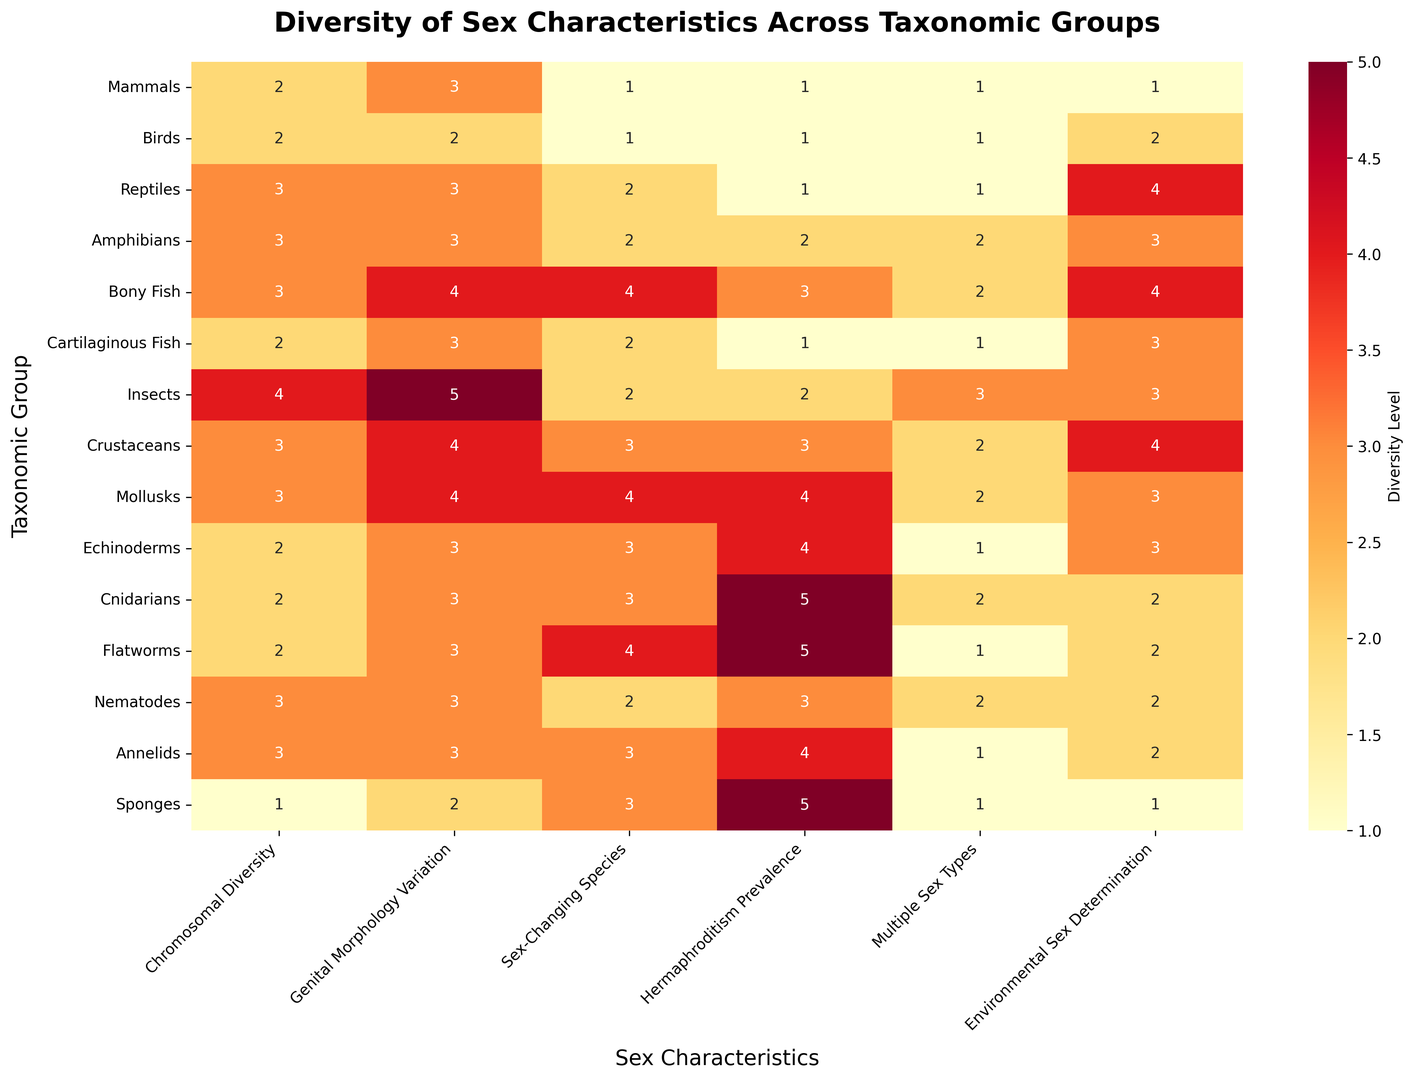Which taxonomic group has the highest level of hermaphroditism prevalence? Look for the cell with the highest value in the "Hermaphroditism Prevalence" column. Cnidarians and Flatworms both have the highest value of 5.
Answer: Cnidarians, Flatworms Which taxonomic group shows the most variation in genital morphology? Look for the highest value in the "Genital Morphology Variation" column. Insects have a value of 5, which is the highest.
Answer: Insects Which taxonomic group has the lowest diversity level in environmental sex determination? Look for the lowest value in the "Environmental Sex Determination" column. Sponges and Mammals both have the lowest value of 1.
Answer: Sponges, Mammals What is the average diversity level of chromosomal diversity across all taxonomic groups? Sum all values in the "Chromosomal Diversity" column and divide by the number of taxonomic groups (15). The sum of the values is 40, so 40/15 gives approximately 2.67.
Answer: 2.67 Which has a higher number of sex-changing species, Amphibians or Bony Fish? Compare the values in the "Sex-Changing Species" column for Amphibians (2) and Bony Fish (4). Bony Fish have a higher value.
Answer: Bony Fish How does the diversity level of multiple sex types in insects compare to that in annelids? Compare the values in the "Multiple Sex Types" column for Insects (3) and Annelids (1). Insects have a higher value.
Answer: Insects have a higher value Which groups exhibit a diversity level of 4 or more in at least three different categories? Check each taxonomic group for diversity levels of 4 or more across at least three categories. Bony Fish, Insects, Crustaceans, Mollusks, and Flatworms meet this criterion.
Answer: Bony Fish, Insects, Crustaceans, Mollusks, Flatworms Which group shows an equal diversity level in both sex-changing species and hermaphroditism prevalence? Look for taxonomic groups where the values in "Sex-Changing Species" and "Hermaphroditism Prevalence" columns are the same. Amphibians and Nematodes both have equal values of 2 and 3 respectively in these columns.
Answer: Amphibians, Nematodes 